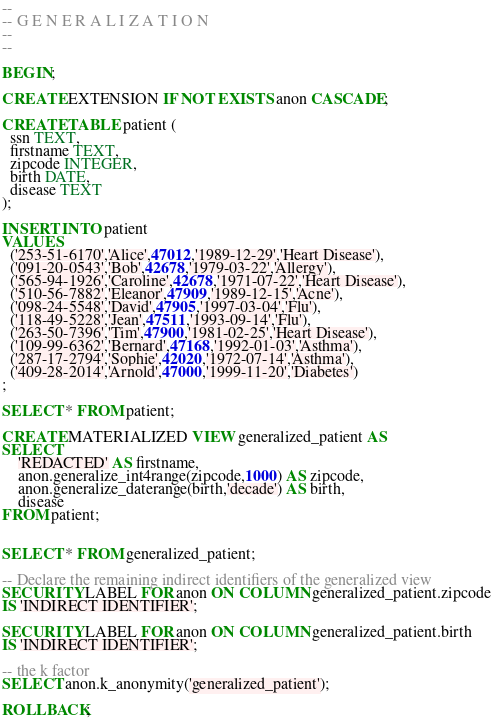Convert code to text. <code><loc_0><loc_0><loc_500><loc_500><_SQL_>--
-- G E N E R A L I Z A T I O N
--
--

BEGIN;

CREATE EXTENSION IF NOT EXISTS anon CASCADE;

CREATE TABLE patient (
  ssn TEXT,
  firstname TEXT,
  zipcode INTEGER,
  birth DATE,
  disease TEXT
);

INSERT INTO patient
VALUES
  ('253-51-6170','Alice',47012,'1989-12-29','Heart Disease'),
  ('091-20-0543','Bob',42678,'1979-03-22','Allergy'),
  ('565-94-1926','Caroline',42678,'1971-07-22','Heart Disease'),
  ('510-56-7882','Eleanor',47909,'1989-12-15','Acne'),
  ('098-24-5548','David',47905,'1997-03-04','Flu'),
  ('118-49-5228','Jean',47511,'1993-09-14','Flu'),
  ('263-50-7396','Tim',47900,'1981-02-25','Heart Disease'),
  ('109-99-6362','Bernard',47168,'1992-01-03','Asthma'),
  ('287-17-2794','Sophie',42020,'1972-07-14','Asthma'),
  ('409-28-2014','Arnold',47000,'1999-11-20','Diabetes')
;

SELECT * FROM patient;

CREATE MATERIALIZED VIEW generalized_patient AS
SELECT
    'REDACTED' AS firstname,
    anon.generalize_int4range(zipcode,1000) AS zipcode,
    anon.generalize_daterange(birth,'decade') AS birth,
    disease
FROM patient;


SELECT * FROM generalized_patient;

-- Declare the remaining indirect identifiers of the generalized view
SECURITY LABEL FOR anon ON COLUMN generalized_patient.zipcode
IS 'INDIRECT IDENTIFIER';

SECURITY LABEL FOR anon ON COLUMN generalized_patient.birth
IS 'INDIRECT IDENTIFIER';

-- the k factor
SELECT anon.k_anonymity('generalized_patient');

ROLLBACK;
</code> 